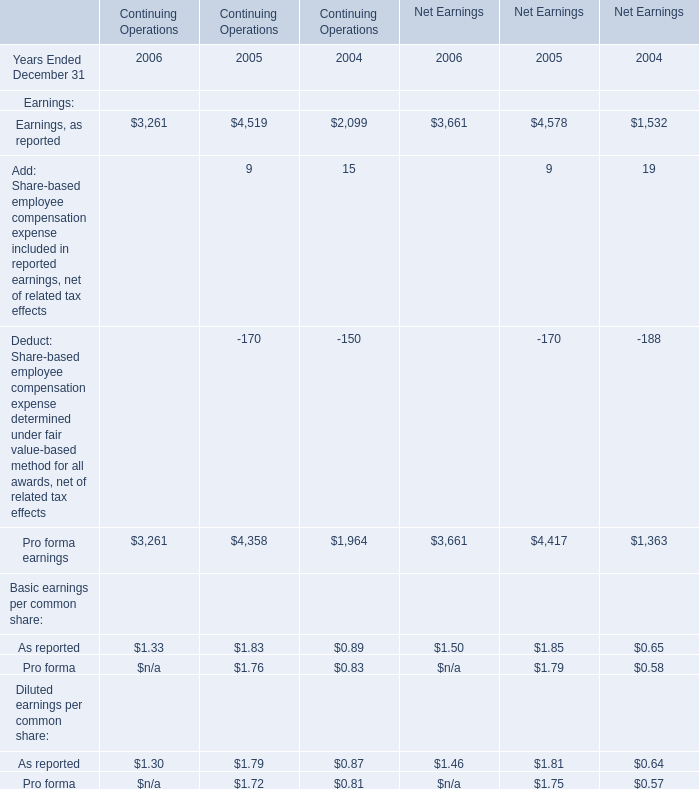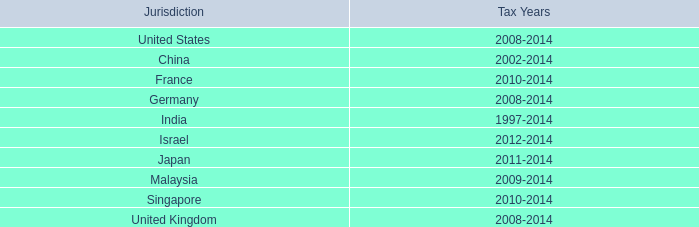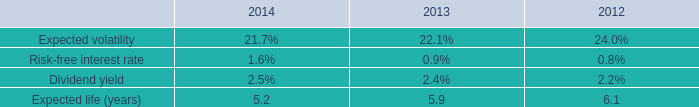what was the percentage change in the weighted-average estimated fair value of employee stock options granted during from 2013 to 2014 
Computations: ((11.02 / 9.52) / 9.52)
Answer: 0.12159. 